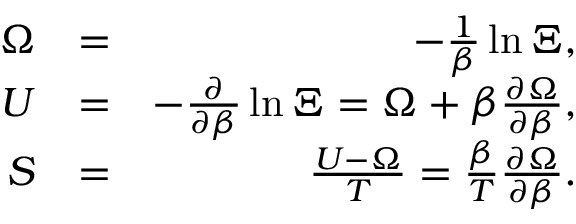<formula> <loc_0><loc_0><loc_500><loc_500>\begin{array} { r l r } { \Omega } & { = } & { - \frac { 1 } { \beta } \ln \Xi , } \\ { U } & { = } & { - \frac { \partial } { \partial \beta } \ln \Xi = \Omega + \beta \frac { \partial \Omega } { \partial \beta } , } \\ { S } & { = } & { \frac { U - \Omega } { T } = \frac { \beta } { T } \frac { \partial \Omega } { \partial \beta } . } \end{array}</formula> 